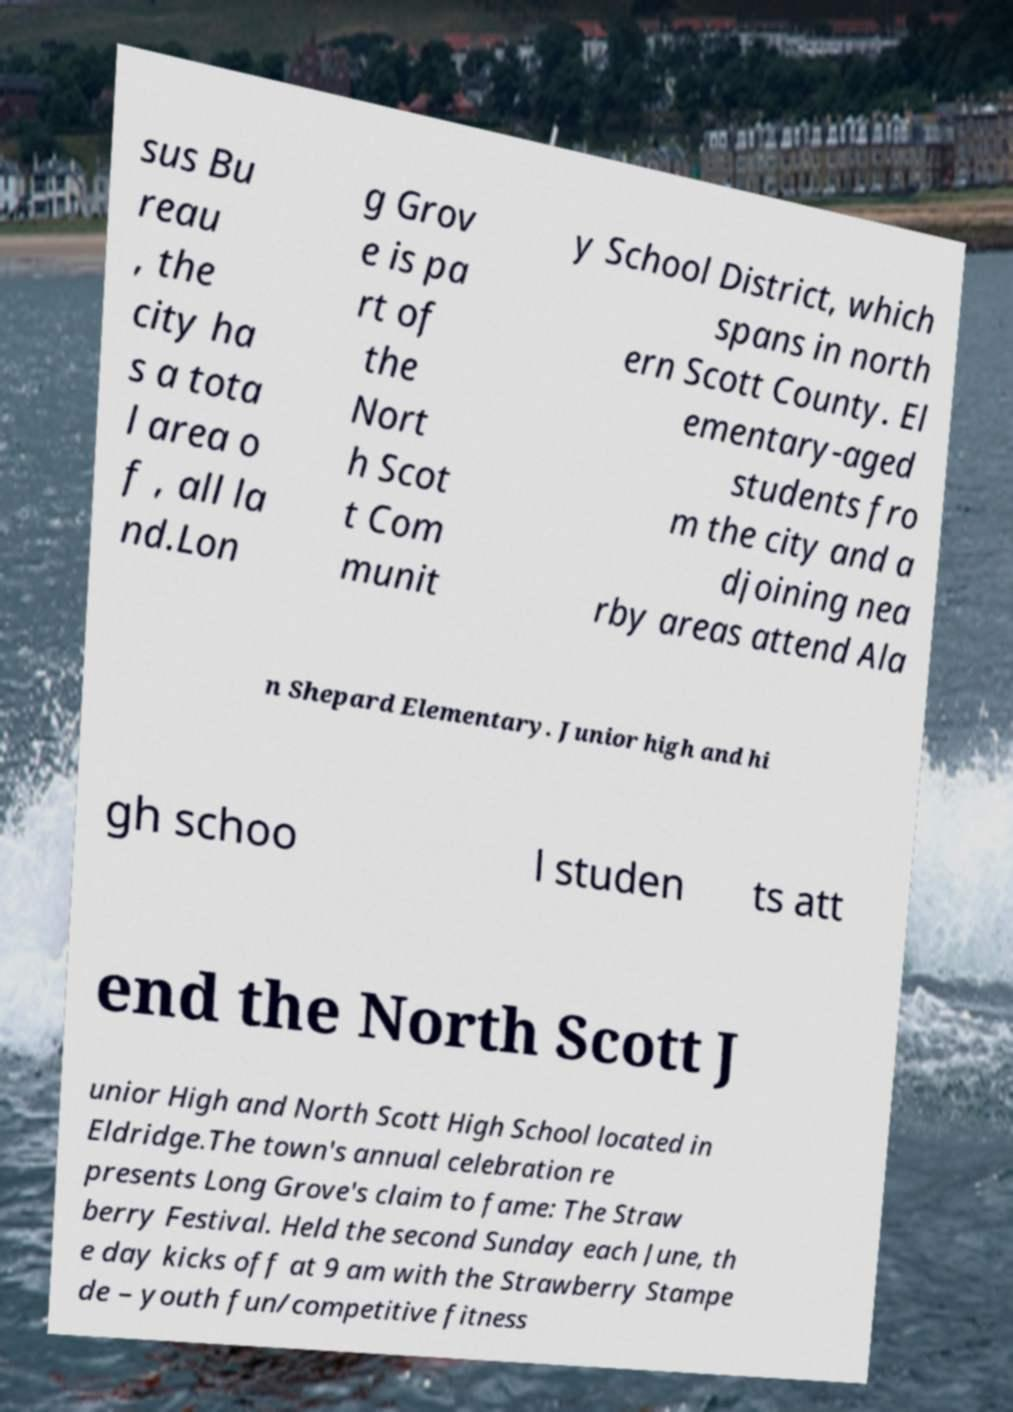Can you accurately transcribe the text from the provided image for me? sus Bu reau , the city ha s a tota l area o f , all la nd.Lon g Grov e is pa rt of the Nort h Scot t Com munit y School District, which spans in north ern Scott County. El ementary-aged students fro m the city and a djoining nea rby areas attend Ala n Shepard Elementary. Junior high and hi gh schoo l studen ts att end the North Scott J unior High and North Scott High School located in Eldridge.The town's annual celebration re presents Long Grove's claim to fame: The Straw berry Festival. Held the second Sunday each June, th e day kicks off at 9 am with the Strawberry Stampe de – youth fun/competitive fitness 